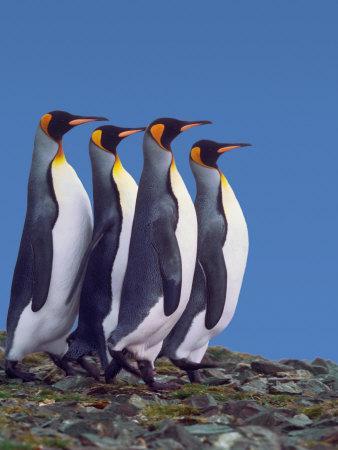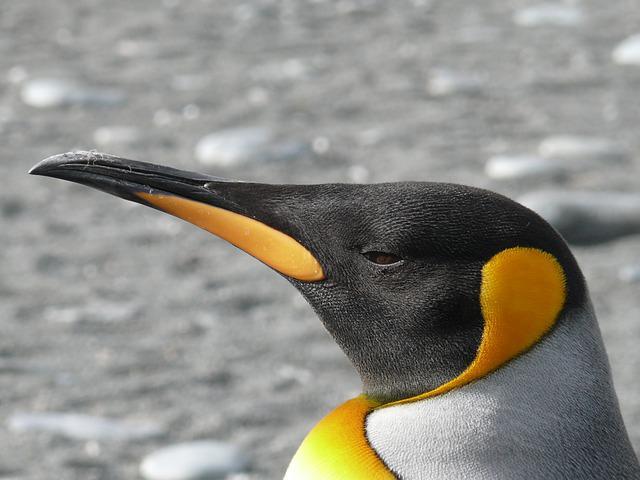The first image is the image on the left, the second image is the image on the right. Analyze the images presented: Is the assertion "There are exactly animals in the image on the right." valid? Answer yes or no. No. 